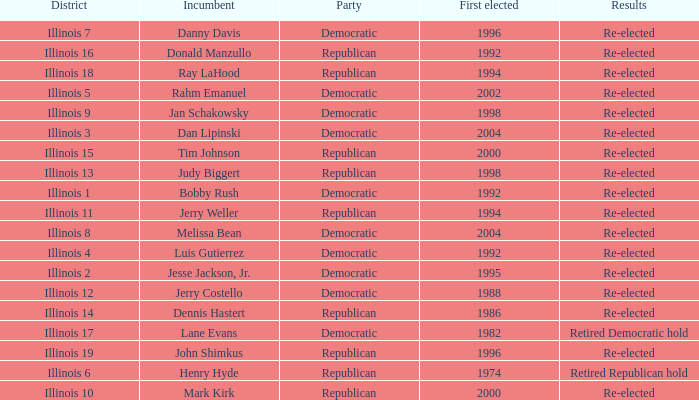What is re-elected Incumbent Jerry Costello's First elected date? 1988.0. 